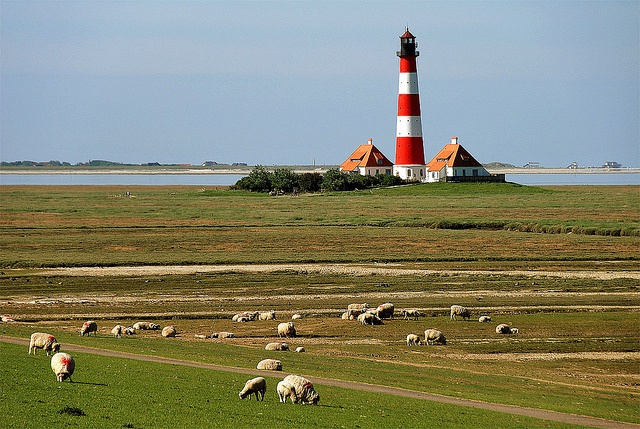Describe the objects in this image and their specific colors. I can see sheep in lightblue, black, olive, and tan tones, sheep in lightblue, black, khaki, beige, and tan tones, sheep in lightblue, black, beige, khaki, and olive tones, sheep in lightblue, khaki, black, and tan tones, and sheep in lightblue, black, khaki, beige, and olive tones in this image. 